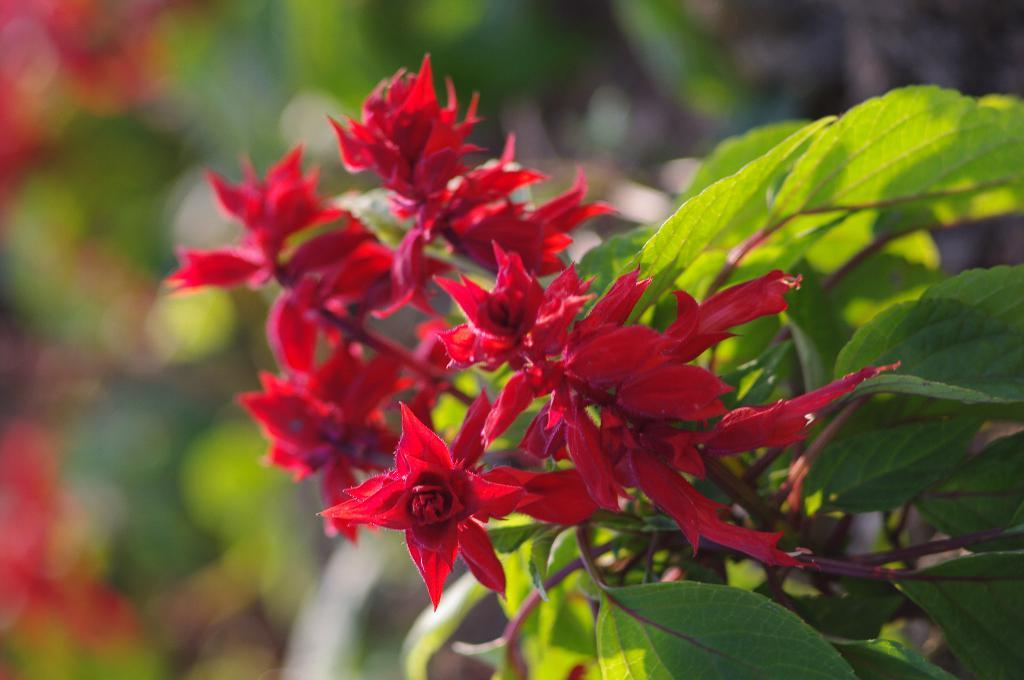What type of vegetation is present in the image? There are trees or plants with flowers in the image. What color are the flowers on the plants? The flowers are red in color. What can be seen in the background of the image? The background of the image is green. How is the background of the image depicted? The background of the image is blurred. What type of grape is being dropped by the son in the image? There is no son or grape present in the image. 